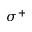<formula> <loc_0><loc_0><loc_500><loc_500>\sigma ^ { + }</formula> 